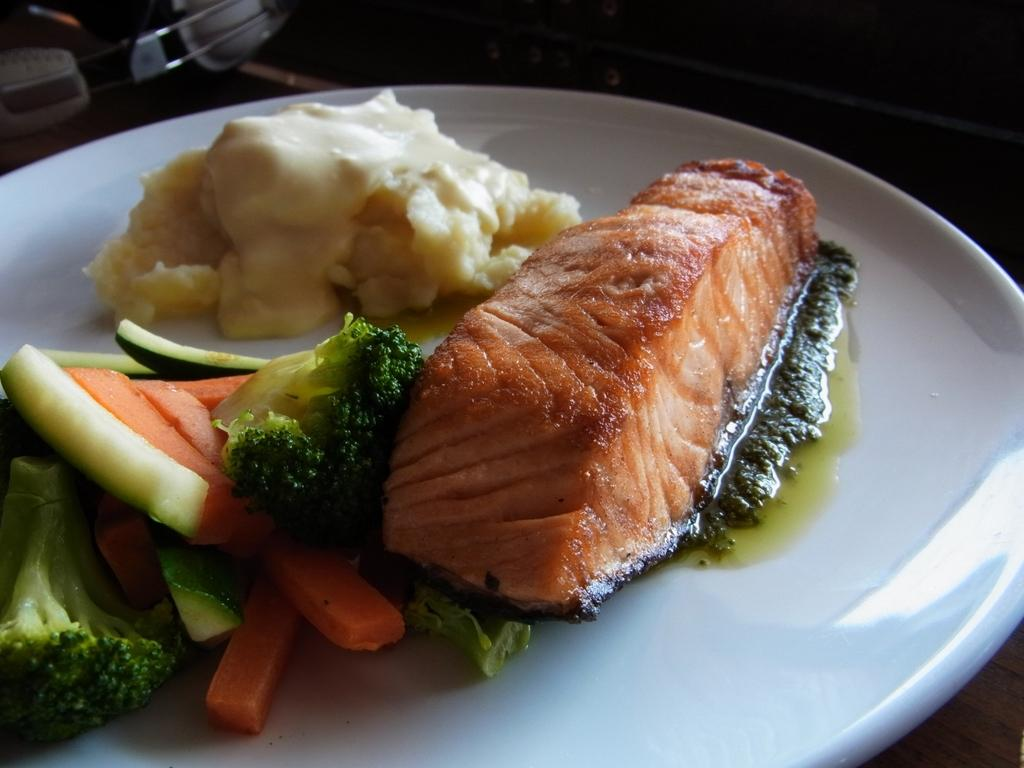What is on the plate that is visible in the image? There is food in a plate in the image. Where is the plate located? The plate is on a wooden platform. What can be seen at the top of the image? There is an object at the top of the image. How many minutes does it take for the food to rest on the plate in the image? The concept of time (minutes) is not relevant to the image, as it only shows a static scene of food on a plate. 